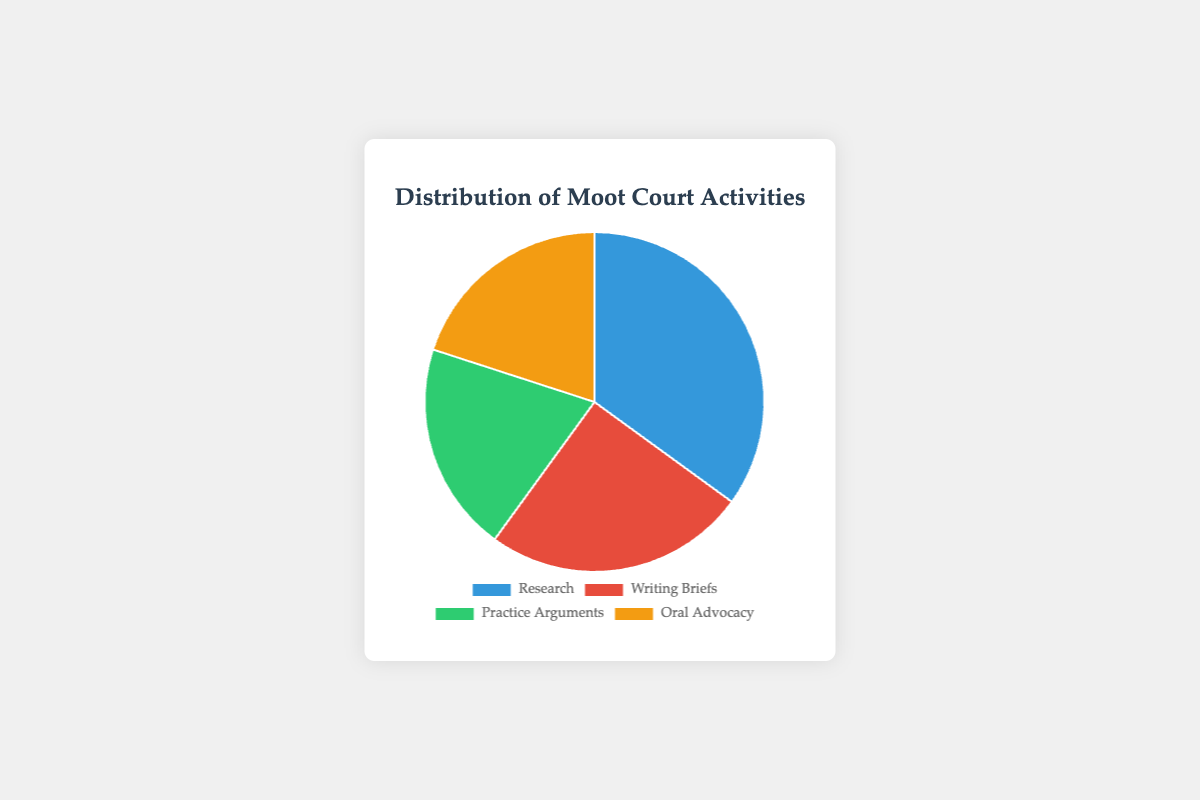What activity takes up the largest portion of time? The pie chart shows the distribution of time among four activities, and by observing the percentages, Research has the highest value at 35%.
Answer: Research Which activities take up an equal amount of time? From the percentages shown on the pie chart, Practice Arguments and Oral Advocacy both take up 20% each.
Answer: Practice Arguments and Oral Advocacy What is the total percentage of time spent on Writing Briefs and Oral Advocacy combined? Add the percentage of Writing Briefs (25%) with Oral Advocacy (20%): 25% + 20% = 45%.
Answer: 45% Which activity has a smaller percentage of time spent compared to Research but larger than Practice Arguments? Research has 35%, Writing Briefs has 25%, Practice Arguments and Oral Advocacy both have 20%. Writing Briefs is smaller than Research but larger than Practice Arguments.
Answer: Writing Briefs What is the difference in percentage points between the activity with the highest percentage and the activity with the lowest percentage? Research is the highest at 35%, and Practice Arguments and Oral Advocacy are the lowest at 20%. The difference is 35% - 20% = 15%.
Answer: 15% What is the percentage of time spent on activities other than Research? Subtract Research percentage from 100%: 100% - 35% = 65%.
Answer: 65% If Writing Briefs and Practice Arguments increased by 5% each, what would be their new percentages? For Writing Briefs: 25% + 5% = 30%, and for Practice Arguments: 20% + 5% = 25%.
Answer: Writing Briefs: 30%, Practice Arguments: 25% Compared to Writing Briefs, how much more time is spent on Research? Research is 35%, Writing Briefs is 25%. The difference in percentage: 35% - 25% = 10%.
Answer: 10% What are the colors associated with Research and Oral Advocacy in the chart? Research is colored blue, and Oral Advocacy is colored orange in the pie chart.
Answer: Research is blue, Oral Advocacy is orange Which activity has the smallest portion represented on the pie chart, and what is its color? Both Practice Arguments and Oral Advocacy have the smallest portion, at 20% each, and are colored green and orange respectively.
Answer: Practice Arguments is green, Oral Advocacy is orange 